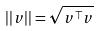<formula> <loc_0><loc_0><loc_500><loc_500>| | v | | = \sqrt { v ^ { \top } v }</formula> 